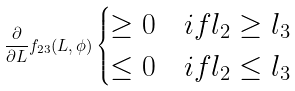<formula> <loc_0><loc_0><loc_500><loc_500>\frac { \partial } { \partial L } f _ { 2 3 } ( L , \phi ) \begin{cases} \geq 0 & i f l _ { 2 } \geq l _ { 3 } \\ \leq 0 & i f l _ { 2 } \leq l _ { 3 } \end{cases}</formula> 